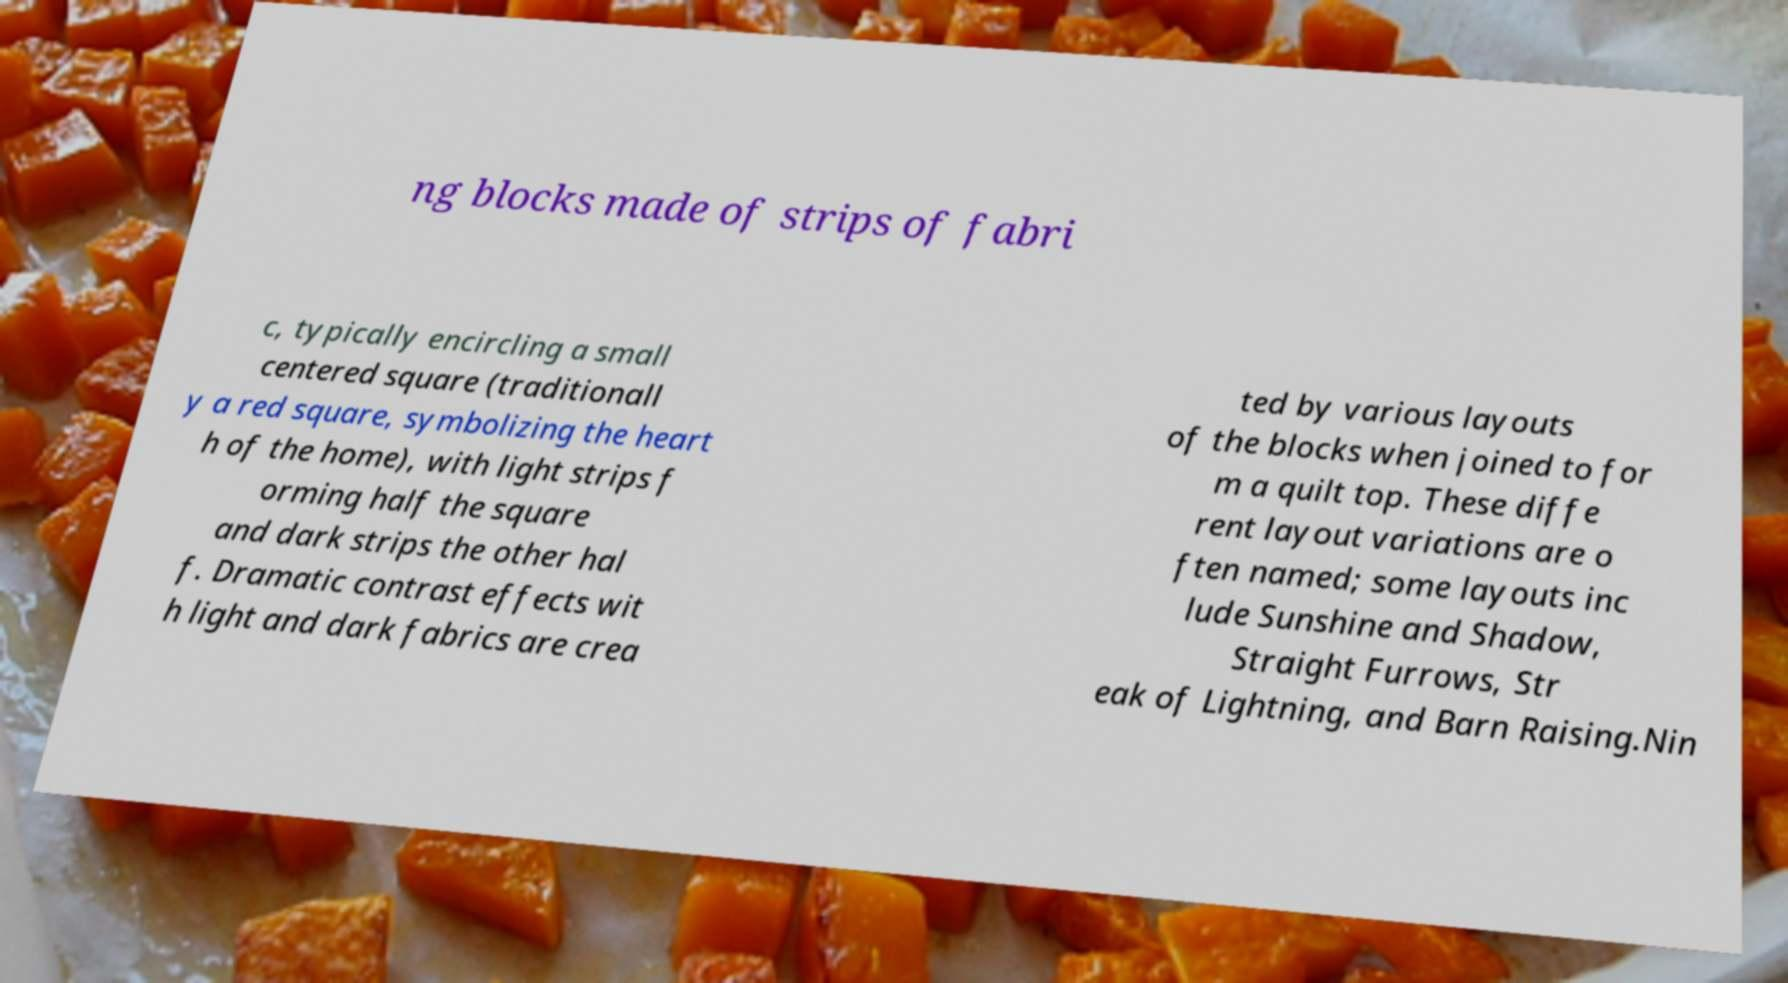For documentation purposes, I need the text within this image transcribed. Could you provide that? ng blocks made of strips of fabri c, typically encircling a small centered square (traditionall y a red square, symbolizing the heart h of the home), with light strips f orming half the square and dark strips the other hal f. Dramatic contrast effects wit h light and dark fabrics are crea ted by various layouts of the blocks when joined to for m a quilt top. These diffe rent layout variations are o ften named; some layouts inc lude Sunshine and Shadow, Straight Furrows, Str eak of Lightning, and Barn Raising.Nin 